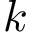Convert formula to latex. <formula><loc_0><loc_0><loc_500><loc_500>k</formula> 